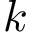Convert formula to latex. <formula><loc_0><loc_0><loc_500><loc_500>k</formula> 